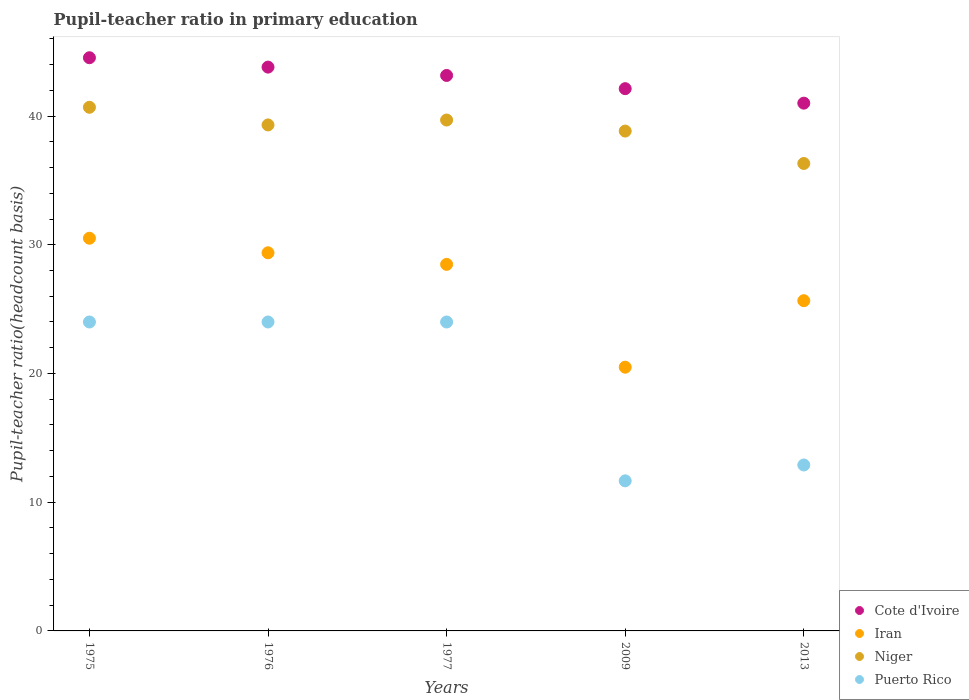How many different coloured dotlines are there?
Provide a short and direct response. 4. What is the pupil-teacher ratio in primary education in Niger in 2009?
Your answer should be compact. 38.83. Across all years, what is the maximum pupil-teacher ratio in primary education in Iran?
Provide a succinct answer. 30.51. Across all years, what is the minimum pupil-teacher ratio in primary education in Iran?
Make the answer very short. 20.49. In which year was the pupil-teacher ratio in primary education in Puerto Rico maximum?
Provide a succinct answer. 1976. In which year was the pupil-teacher ratio in primary education in Cote d'Ivoire minimum?
Make the answer very short. 2013. What is the total pupil-teacher ratio in primary education in Cote d'Ivoire in the graph?
Ensure brevity in your answer.  214.61. What is the difference between the pupil-teacher ratio in primary education in Niger in 1976 and that in 2013?
Your answer should be very brief. 2.99. What is the difference between the pupil-teacher ratio in primary education in Iran in 2013 and the pupil-teacher ratio in primary education in Cote d'Ivoire in 1977?
Provide a short and direct response. -17.5. What is the average pupil-teacher ratio in primary education in Iran per year?
Your response must be concise. 26.9. In the year 1977, what is the difference between the pupil-teacher ratio in primary education in Cote d'Ivoire and pupil-teacher ratio in primary education in Puerto Rico?
Ensure brevity in your answer.  19.15. What is the ratio of the pupil-teacher ratio in primary education in Niger in 1977 to that in 2013?
Make the answer very short. 1.09. What is the difference between the highest and the second highest pupil-teacher ratio in primary education in Cote d'Ivoire?
Offer a terse response. 0.73. What is the difference between the highest and the lowest pupil-teacher ratio in primary education in Cote d'Ivoire?
Provide a short and direct response. 3.53. Is it the case that in every year, the sum of the pupil-teacher ratio in primary education in Niger and pupil-teacher ratio in primary education in Iran  is greater than the pupil-teacher ratio in primary education in Puerto Rico?
Offer a very short reply. Yes. Is the pupil-teacher ratio in primary education in Niger strictly greater than the pupil-teacher ratio in primary education in Iran over the years?
Provide a succinct answer. Yes. Is the pupil-teacher ratio in primary education in Iran strictly less than the pupil-teacher ratio in primary education in Cote d'Ivoire over the years?
Offer a terse response. Yes. How many years are there in the graph?
Make the answer very short. 5. Where does the legend appear in the graph?
Make the answer very short. Bottom right. How many legend labels are there?
Provide a succinct answer. 4. What is the title of the graph?
Ensure brevity in your answer.  Pupil-teacher ratio in primary education. Does "Burkina Faso" appear as one of the legend labels in the graph?
Offer a terse response. No. What is the label or title of the Y-axis?
Keep it short and to the point. Pupil-teacher ratio(headcount basis). What is the Pupil-teacher ratio(headcount basis) of Cote d'Ivoire in 1975?
Ensure brevity in your answer.  44.53. What is the Pupil-teacher ratio(headcount basis) of Iran in 1975?
Provide a short and direct response. 30.51. What is the Pupil-teacher ratio(headcount basis) of Niger in 1975?
Offer a terse response. 40.68. What is the Pupil-teacher ratio(headcount basis) of Puerto Rico in 1975?
Your answer should be very brief. 24. What is the Pupil-teacher ratio(headcount basis) in Cote d'Ivoire in 1976?
Your answer should be compact. 43.8. What is the Pupil-teacher ratio(headcount basis) in Iran in 1976?
Keep it short and to the point. 29.38. What is the Pupil-teacher ratio(headcount basis) of Niger in 1976?
Provide a succinct answer. 39.31. What is the Pupil-teacher ratio(headcount basis) in Puerto Rico in 1976?
Your answer should be very brief. 24. What is the Pupil-teacher ratio(headcount basis) in Cote d'Ivoire in 1977?
Your answer should be very brief. 43.15. What is the Pupil-teacher ratio(headcount basis) of Iran in 1977?
Your answer should be very brief. 28.48. What is the Pupil-teacher ratio(headcount basis) in Niger in 1977?
Make the answer very short. 39.69. What is the Pupil-teacher ratio(headcount basis) of Puerto Rico in 1977?
Keep it short and to the point. 24. What is the Pupil-teacher ratio(headcount basis) in Cote d'Ivoire in 2009?
Offer a very short reply. 42.13. What is the Pupil-teacher ratio(headcount basis) in Iran in 2009?
Offer a very short reply. 20.49. What is the Pupil-teacher ratio(headcount basis) in Niger in 2009?
Provide a succinct answer. 38.83. What is the Pupil-teacher ratio(headcount basis) in Puerto Rico in 2009?
Keep it short and to the point. 11.66. What is the Pupil-teacher ratio(headcount basis) of Cote d'Ivoire in 2013?
Make the answer very short. 41. What is the Pupil-teacher ratio(headcount basis) of Iran in 2013?
Give a very brief answer. 25.65. What is the Pupil-teacher ratio(headcount basis) in Niger in 2013?
Keep it short and to the point. 36.31. What is the Pupil-teacher ratio(headcount basis) of Puerto Rico in 2013?
Give a very brief answer. 12.89. Across all years, what is the maximum Pupil-teacher ratio(headcount basis) in Cote d'Ivoire?
Keep it short and to the point. 44.53. Across all years, what is the maximum Pupil-teacher ratio(headcount basis) in Iran?
Ensure brevity in your answer.  30.51. Across all years, what is the maximum Pupil-teacher ratio(headcount basis) of Niger?
Your response must be concise. 40.68. Across all years, what is the maximum Pupil-teacher ratio(headcount basis) of Puerto Rico?
Ensure brevity in your answer.  24. Across all years, what is the minimum Pupil-teacher ratio(headcount basis) in Cote d'Ivoire?
Your response must be concise. 41. Across all years, what is the minimum Pupil-teacher ratio(headcount basis) of Iran?
Your answer should be very brief. 20.49. Across all years, what is the minimum Pupil-teacher ratio(headcount basis) of Niger?
Make the answer very short. 36.31. Across all years, what is the minimum Pupil-teacher ratio(headcount basis) in Puerto Rico?
Provide a succinct answer. 11.66. What is the total Pupil-teacher ratio(headcount basis) of Cote d'Ivoire in the graph?
Provide a succinct answer. 214.61. What is the total Pupil-teacher ratio(headcount basis) of Iran in the graph?
Provide a short and direct response. 134.5. What is the total Pupil-teacher ratio(headcount basis) of Niger in the graph?
Your response must be concise. 194.83. What is the total Pupil-teacher ratio(headcount basis) in Puerto Rico in the graph?
Keep it short and to the point. 96.55. What is the difference between the Pupil-teacher ratio(headcount basis) of Cote d'Ivoire in 1975 and that in 1976?
Offer a very short reply. 0.73. What is the difference between the Pupil-teacher ratio(headcount basis) in Iran in 1975 and that in 1976?
Make the answer very short. 1.13. What is the difference between the Pupil-teacher ratio(headcount basis) of Niger in 1975 and that in 1976?
Provide a succinct answer. 1.37. What is the difference between the Pupil-teacher ratio(headcount basis) of Puerto Rico in 1975 and that in 1976?
Provide a succinct answer. -0. What is the difference between the Pupil-teacher ratio(headcount basis) of Cote d'Ivoire in 1975 and that in 1977?
Your answer should be very brief. 1.38. What is the difference between the Pupil-teacher ratio(headcount basis) of Iran in 1975 and that in 1977?
Provide a succinct answer. 2.03. What is the difference between the Pupil-teacher ratio(headcount basis) in Niger in 1975 and that in 1977?
Make the answer very short. 0.99. What is the difference between the Pupil-teacher ratio(headcount basis) of Cote d'Ivoire in 1975 and that in 2009?
Your answer should be very brief. 2.4. What is the difference between the Pupil-teacher ratio(headcount basis) of Iran in 1975 and that in 2009?
Your response must be concise. 10.02. What is the difference between the Pupil-teacher ratio(headcount basis) in Niger in 1975 and that in 2009?
Keep it short and to the point. 1.85. What is the difference between the Pupil-teacher ratio(headcount basis) of Puerto Rico in 1975 and that in 2009?
Offer a very short reply. 12.34. What is the difference between the Pupil-teacher ratio(headcount basis) in Cote d'Ivoire in 1975 and that in 2013?
Your answer should be compact. 3.53. What is the difference between the Pupil-teacher ratio(headcount basis) in Iran in 1975 and that in 2013?
Offer a very short reply. 4.85. What is the difference between the Pupil-teacher ratio(headcount basis) of Niger in 1975 and that in 2013?
Provide a succinct answer. 4.37. What is the difference between the Pupil-teacher ratio(headcount basis) in Puerto Rico in 1975 and that in 2013?
Your response must be concise. 11.11. What is the difference between the Pupil-teacher ratio(headcount basis) of Cote d'Ivoire in 1976 and that in 1977?
Provide a succinct answer. 0.65. What is the difference between the Pupil-teacher ratio(headcount basis) in Iran in 1976 and that in 1977?
Ensure brevity in your answer.  0.9. What is the difference between the Pupil-teacher ratio(headcount basis) of Niger in 1976 and that in 1977?
Give a very brief answer. -0.38. What is the difference between the Pupil-teacher ratio(headcount basis) in Puerto Rico in 1976 and that in 1977?
Offer a very short reply. 0. What is the difference between the Pupil-teacher ratio(headcount basis) in Cote d'Ivoire in 1976 and that in 2009?
Provide a succinct answer. 1.67. What is the difference between the Pupil-teacher ratio(headcount basis) in Iran in 1976 and that in 2009?
Your answer should be compact. 8.89. What is the difference between the Pupil-teacher ratio(headcount basis) of Niger in 1976 and that in 2009?
Provide a short and direct response. 0.48. What is the difference between the Pupil-teacher ratio(headcount basis) of Puerto Rico in 1976 and that in 2009?
Your response must be concise. 12.34. What is the difference between the Pupil-teacher ratio(headcount basis) of Cote d'Ivoire in 1976 and that in 2013?
Your answer should be very brief. 2.8. What is the difference between the Pupil-teacher ratio(headcount basis) in Iran in 1976 and that in 2013?
Give a very brief answer. 3.72. What is the difference between the Pupil-teacher ratio(headcount basis) of Niger in 1976 and that in 2013?
Your answer should be compact. 2.99. What is the difference between the Pupil-teacher ratio(headcount basis) of Puerto Rico in 1976 and that in 2013?
Your response must be concise. 11.11. What is the difference between the Pupil-teacher ratio(headcount basis) in Cote d'Ivoire in 1977 and that in 2009?
Provide a succinct answer. 1.03. What is the difference between the Pupil-teacher ratio(headcount basis) of Iran in 1977 and that in 2009?
Your answer should be compact. 7.99. What is the difference between the Pupil-teacher ratio(headcount basis) of Niger in 1977 and that in 2009?
Provide a succinct answer. 0.86. What is the difference between the Pupil-teacher ratio(headcount basis) of Puerto Rico in 1977 and that in 2009?
Give a very brief answer. 12.34. What is the difference between the Pupil-teacher ratio(headcount basis) of Cote d'Ivoire in 1977 and that in 2013?
Give a very brief answer. 2.15. What is the difference between the Pupil-teacher ratio(headcount basis) in Iran in 1977 and that in 2013?
Your answer should be very brief. 2.82. What is the difference between the Pupil-teacher ratio(headcount basis) of Niger in 1977 and that in 2013?
Offer a terse response. 3.38. What is the difference between the Pupil-teacher ratio(headcount basis) of Puerto Rico in 1977 and that in 2013?
Offer a very short reply. 11.11. What is the difference between the Pupil-teacher ratio(headcount basis) in Cote d'Ivoire in 2009 and that in 2013?
Make the answer very short. 1.13. What is the difference between the Pupil-teacher ratio(headcount basis) of Iran in 2009 and that in 2013?
Provide a short and direct response. -5.17. What is the difference between the Pupil-teacher ratio(headcount basis) of Niger in 2009 and that in 2013?
Offer a very short reply. 2.52. What is the difference between the Pupil-teacher ratio(headcount basis) in Puerto Rico in 2009 and that in 2013?
Provide a short and direct response. -1.23. What is the difference between the Pupil-teacher ratio(headcount basis) in Cote d'Ivoire in 1975 and the Pupil-teacher ratio(headcount basis) in Iran in 1976?
Ensure brevity in your answer.  15.15. What is the difference between the Pupil-teacher ratio(headcount basis) in Cote d'Ivoire in 1975 and the Pupil-teacher ratio(headcount basis) in Niger in 1976?
Provide a short and direct response. 5.22. What is the difference between the Pupil-teacher ratio(headcount basis) of Cote d'Ivoire in 1975 and the Pupil-teacher ratio(headcount basis) of Puerto Rico in 1976?
Your response must be concise. 20.53. What is the difference between the Pupil-teacher ratio(headcount basis) of Iran in 1975 and the Pupil-teacher ratio(headcount basis) of Niger in 1976?
Ensure brevity in your answer.  -8.8. What is the difference between the Pupil-teacher ratio(headcount basis) of Iran in 1975 and the Pupil-teacher ratio(headcount basis) of Puerto Rico in 1976?
Give a very brief answer. 6.51. What is the difference between the Pupil-teacher ratio(headcount basis) of Niger in 1975 and the Pupil-teacher ratio(headcount basis) of Puerto Rico in 1976?
Offer a terse response. 16.68. What is the difference between the Pupil-teacher ratio(headcount basis) in Cote d'Ivoire in 1975 and the Pupil-teacher ratio(headcount basis) in Iran in 1977?
Offer a very short reply. 16.05. What is the difference between the Pupil-teacher ratio(headcount basis) in Cote d'Ivoire in 1975 and the Pupil-teacher ratio(headcount basis) in Niger in 1977?
Give a very brief answer. 4.84. What is the difference between the Pupil-teacher ratio(headcount basis) of Cote d'Ivoire in 1975 and the Pupil-teacher ratio(headcount basis) of Puerto Rico in 1977?
Your answer should be very brief. 20.53. What is the difference between the Pupil-teacher ratio(headcount basis) of Iran in 1975 and the Pupil-teacher ratio(headcount basis) of Niger in 1977?
Provide a short and direct response. -9.18. What is the difference between the Pupil-teacher ratio(headcount basis) of Iran in 1975 and the Pupil-teacher ratio(headcount basis) of Puerto Rico in 1977?
Your answer should be very brief. 6.51. What is the difference between the Pupil-teacher ratio(headcount basis) of Niger in 1975 and the Pupil-teacher ratio(headcount basis) of Puerto Rico in 1977?
Offer a terse response. 16.68. What is the difference between the Pupil-teacher ratio(headcount basis) in Cote d'Ivoire in 1975 and the Pupil-teacher ratio(headcount basis) in Iran in 2009?
Give a very brief answer. 24.04. What is the difference between the Pupil-teacher ratio(headcount basis) of Cote d'Ivoire in 1975 and the Pupil-teacher ratio(headcount basis) of Niger in 2009?
Provide a succinct answer. 5.7. What is the difference between the Pupil-teacher ratio(headcount basis) of Cote d'Ivoire in 1975 and the Pupil-teacher ratio(headcount basis) of Puerto Rico in 2009?
Offer a terse response. 32.87. What is the difference between the Pupil-teacher ratio(headcount basis) of Iran in 1975 and the Pupil-teacher ratio(headcount basis) of Niger in 2009?
Keep it short and to the point. -8.32. What is the difference between the Pupil-teacher ratio(headcount basis) in Iran in 1975 and the Pupil-teacher ratio(headcount basis) in Puerto Rico in 2009?
Your answer should be very brief. 18.85. What is the difference between the Pupil-teacher ratio(headcount basis) in Niger in 1975 and the Pupil-teacher ratio(headcount basis) in Puerto Rico in 2009?
Provide a succinct answer. 29.02. What is the difference between the Pupil-teacher ratio(headcount basis) in Cote d'Ivoire in 1975 and the Pupil-teacher ratio(headcount basis) in Iran in 2013?
Provide a short and direct response. 18.88. What is the difference between the Pupil-teacher ratio(headcount basis) of Cote d'Ivoire in 1975 and the Pupil-teacher ratio(headcount basis) of Niger in 2013?
Your response must be concise. 8.22. What is the difference between the Pupil-teacher ratio(headcount basis) of Cote d'Ivoire in 1975 and the Pupil-teacher ratio(headcount basis) of Puerto Rico in 2013?
Your answer should be very brief. 31.64. What is the difference between the Pupil-teacher ratio(headcount basis) in Iran in 1975 and the Pupil-teacher ratio(headcount basis) in Niger in 2013?
Your answer should be very brief. -5.81. What is the difference between the Pupil-teacher ratio(headcount basis) of Iran in 1975 and the Pupil-teacher ratio(headcount basis) of Puerto Rico in 2013?
Provide a short and direct response. 17.62. What is the difference between the Pupil-teacher ratio(headcount basis) of Niger in 1975 and the Pupil-teacher ratio(headcount basis) of Puerto Rico in 2013?
Keep it short and to the point. 27.79. What is the difference between the Pupil-teacher ratio(headcount basis) in Cote d'Ivoire in 1976 and the Pupil-teacher ratio(headcount basis) in Iran in 1977?
Provide a succinct answer. 15.33. What is the difference between the Pupil-teacher ratio(headcount basis) of Cote d'Ivoire in 1976 and the Pupil-teacher ratio(headcount basis) of Niger in 1977?
Keep it short and to the point. 4.11. What is the difference between the Pupil-teacher ratio(headcount basis) of Cote d'Ivoire in 1976 and the Pupil-teacher ratio(headcount basis) of Puerto Rico in 1977?
Your answer should be very brief. 19.8. What is the difference between the Pupil-teacher ratio(headcount basis) in Iran in 1976 and the Pupil-teacher ratio(headcount basis) in Niger in 1977?
Provide a short and direct response. -10.31. What is the difference between the Pupil-teacher ratio(headcount basis) in Iran in 1976 and the Pupil-teacher ratio(headcount basis) in Puerto Rico in 1977?
Your answer should be very brief. 5.38. What is the difference between the Pupil-teacher ratio(headcount basis) of Niger in 1976 and the Pupil-teacher ratio(headcount basis) of Puerto Rico in 1977?
Ensure brevity in your answer.  15.31. What is the difference between the Pupil-teacher ratio(headcount basis) in Cote d'Ivoire in 1976 and the Pupil-teacher ratio(headcount basis) in Iran in 2009?
Make the answer very short. 23.31. What is the difference between the Pupil-teacher ratio(headcount basis) in Cote d'Ivoire in 1976 and the Pupil-teacher ratio(headcount basis) in Niger in 2009?
Provide a succinct answer. 4.97. What is the difference between the Pupil-teacher ratio(headcount basis) in Cote d'Ivoire in 1976 and the Pupil-teacher ratio(headcount basis) in Puerto Rico in 2009?
Your response must be concise. 32.14. What is the difference between the Pupil-teacher ratio(headcount basis) of Iran in 1976 and the Pupil-teacher ratio(headcount basis) of Niger in 2009?
Provide a succinct answer. -9.46. What is the difference between the Pupil-teacher ratio(headcount basis) in Iran in 1976 and the Pupil-teacher ratio(headcount basis) in Puerto Rico in 2009?
Offer a very short reply. 17.72. What is the difference between the Pupil-teacher ratio(headcount basis) in Niger in 1976 and the Pupil-teacher ratio(headcount basis) in Puerto Rico in 2009?
Your answer should be very brief. 27.65. What is the difference between the Pupil-teacher ratio(headcount basis) of Cote d'Ivoire in 1976 and the Pupil-teacher ratio(headcount basis) of Iran in 2013?
Make the answer very short. 18.15. What is the difference between the Pupil-teacher ratio(headcount basis) of Cote d'Ivoire in 1976 and the Pupil-teacher ratio(headcount basis) of Niger in 2013?
Offer a terse response. 7.49. What is the difference between the Pupil-teacher ratio(headcount basis) of Cote d'Ivoire in 1976 and the Pupil-teacher ratio(headcount basis) of Puerto Rico in 2013?
Your answer should be very brief. 30.91. What is the difference between the Pupil-teacher ratio(headcount basis) in Iran in 1976 and the Pupil-teacher ratio(headcount basis) in Niger in 2013?
Give a very brief answer. -6.94. What is the difference between the Pupil-teacher ratio(headcount basis) in Iran in 1976 and the Pupil-teacher ratio(headcount basis) in Puerto Rico in 2013?
Your answer should be compact. 16.48. What is the difference between the Pupil-teacher ratio(headcount basis) in Niger in 1976 and the Pupil-teacher ratio(headcount basis) in Puerto Rico in 2013?
Your answer should be compact. 26.42. What is the difference between the Pupil-teacher ratio(headcount basis) in Cote d'Ivoire in 1977 and the Pupil-teacher ratio(headcount basis) in Iran in 2009?
Your answer should be compact. 22.67. What is the difference between the Pupil-teacher ratio(headcount basis) in Cote d'Ivoire in 1977 and the Pupil-teacher ratio(headcount basis) in Niger in 2009?
Offer a very short reply. 4.32. What is the difference between the Pupil-teacher ratio(headcount basis) in Cote d'Ivoire in 1977 and the Pupil-teacher ratio(headcount basis) in Puerto Rico in 2009?
Your response must be concise. 31.49. What is the difference between the Pupil-teacher ratio(headcount basis) of Iran in 1977 and the Pupil-teacher ratio(headcount basis) of Niger in 2009?
Give a very brief answer. -10.36. What is the difference between the Pupil-teacher ratio(headcount basis) in Iran in 1977 and the Pupil-teacher ratio(headcount basis) in Puerto Rico in 2009?
Give a very brief answer. 16.82. What is the difference between the Pupil-teacher ratio(headcount basis) in Niger in 1977 and the Pupil-teacher ratio(headcount basis) in Puerto Rico in 2009?
Offer a terse response. 28.03. What is the difference between the Pupil-teacher ratio(headcount basis) of Cote d'Ivoire in 1977 and the Pupil-teacher ratio(headcount basis) of Iran in 2013?
Keep it short and to the point. 17.5. What is the difference between the Pupil-teacher ratio(headcount basis) in Cote d'Ivoire in 1977 and the Pupil-teacher ratio(headcount basis) in Niger in 2013?
Your answer should be very brief. 6.84. What is the difference between the Pupil-teacher ratio(headcount basis) in Cote d'Ivoire in 1977 and the Pupil-teacher ratio(headcount basis) in Puerto Rico in 2013?
Ensure brevity in your answer.  30.26. What is the difference between the Pupil-teacher ratio(headcount basis) of Iran in 1977 and the Pupil-teacher ratio(headcount basis) of Niger in 2013?
Make the answer very short. -7.84. What is the difference between the Pupil-teacher ratio(headcount basis) of Iran in 1977 and the Pupil-teacher ratio(headcount basis) of Puerto Rico in 2013?
Your response must be concise. 15.58. What is the difference between the Pupil-teacher ratio(headcount basis) of Niger in 1977 and the Pupil-teacher ratio(headcount basis) of Puerto Rico in 2013?
Your response must be concise. 26.8. What is the difference between the Pupil-teacher ratio(headcount basis) in Cote d'Ivoire in 2009 and the Pupil-teacher ratio(headcount basis) in Iran in 2013?
Provide a short and direct response. 16.47. What is the difference between the Pupil-teacher ratio(headcount basis) of Cote d'Ivoire in 2009 and the Pupil-teacher ratio(headcount basis) of Niger in 2013?
Provide a succinct answer. 5.81. What is the difference between the Pupil-teacher ratio(headcount basis) of Cote d'Ivoire in 2009 and the Pupil-teacher ratio(headcount basis) of Puerto Rico in 2013?
Your answer should be very brief. 29.24. What is the difference between the Pupil-teacher ratio(headcount basis) in Iran in 2009 and the Pupil-teacher ratio(headcount basis) in Niger in 2013?
Make the answer very short. -15.83. What is the difference between the Pupil-teacher ratio(headcount basis) of Iran in 2009 and the Pupil-teacher ratio(headcount basis) of Puerto Rico in 2013?
Ensure brevity in your answer.  7.6. What is the difference between the Pupil-teacher ratio(headcount basis) in Niger in 2009 and the Pupil-teacher ratio(headcount basis) in Puerto Rico in 2013?
Your response must be concise. 25.94. What is the average Pupil-teacher ratio(headcount basis) in Cote d'Ivoire per year?
Offer a very short reply. 42.92. What is the average Pupil-teacher ratio(headcount basis) in Iran per year?
Provide a short and direct response. 26.9. What is the average Pupil-teacher ratio(headcount basis) in Niger per year?
Offer a terse response. 38.97. What is the average Pupil-teacher ratio(headcount basis) in Puerto Rico per year?
Your answer should be very brief. 19.31. In the year 1975, what is the difference between the Pupil-teacher ratio(headcount basis) in Cote d'Ivoire and Pupil-teacher ratio(headcount basis) in Iran?
Offer a very short reply. 14.02. In the year 1975, what is the difference between the Pupil-teacher ratio(headcount basis) of Cote d'Ivoire and Pupil-teacher ratio(headcount basis) of Niger?
Provide a short and direct response. 3.85. In the year 1975, what is the difference between the Pupil-teacher ratio(headcount basis) of Cote d'Ivoire and Pupil-teacher ratio(headcount basis) of Puerto Rico?
Ensure brevity in your answer.  20.53. In the year 1975, what is the difference between the Pupil-teacher ratio(headcount basis) in Iran and Pupil-teacher ratio(headcount basis) in Niger?
Your answer should be very brief. -10.17. In the year 1975, what is the difference between the Pupil-teacher ratio(headcount basis) in Iran and Pupil-teacher ratio(headcount basis) in Puerto Rico?
Give a very brief answer. 6.51. In the year 1975, what is the difference between the Pupil-teacher ratio(headcount basis) of Niger and Pupil-teacher ratio(headcount basis) of Puerto Rico?
Offer a very short reply. 16.68. In the year 1976, what is the difference between the Pupil-teacher ratio(headcount basis) of Cote d'Ivoire and Pupil-teacher ratio(headcount basis) of Iran?
Keep it short and to the point. 14.43. In the year 1976, what is the difference between the Pupil-teacher ratio(headcount basis) in Cote d'Ivoire and Pupil-teacher ratio(headcount basis) in Niger?
Your answer should be very brief. 4.49. In the year 1976, what is the difference between the Pupil-teacher ratio(headcount basis) in Cote d'Ivoire and Pupil-teacher ratio(headcount basis) in Puerto Rico?
Give a very brief answer. 19.8. In the year 1976, what is the difference between the Pupil-teacher ratio(headcount basis) of Iran and Pupil-teacher ratio(headcount basis) of Niger?
Keep it short and to the point. -9.93. In the year 1976, what is the difference between the Pupil-teacher ratio(headcount basis) of Iran and Pupil-teacher ratio(headcount basis) of Puerto Rico?
Your response must be concise. 5.37. In the year 1976, what is the difference between the Pupil-teacher ratio(headcount basis) in Niger and Pupil-teacher ratio(headcount basis) in Puerto Rico?
Keep it short and to the point. 15.31. In the year 1977, what is the difference between the Pupil-teacher ratio(headcount basis) in Cote d'Ivoire and Pupil-teacher ratio(headcount basis) in Iran?
Provide a succinct answer. 14.68. In the year 1977, what is the difference between the Pupil-teacher ratio(headcount basis) of Cote d'Ivoire and Pupil-teacher ratio(headcount basis) of Niger?
Provide a succinct answer. 3.46. In the year 1977, what is the difference between the Pupil-teacher ratio(headcount basis) in Cote d'Ivoire and Pupil-teacher ratio(headcount basis) in Puerto Rico?
Ensure brevity in your answer.  19.15. In the year 1977, what is the difference between the Pupil-teacher ratio(headcount basis) in Iran and Pupil-teacher ratio(headcount basis) in Niger?
Offer a very short reply. -11.21. In the year 1977, what is the difference between the Pupil-teacher ratio(headcount basis) of Iran and Pupil-teacher ratio(headcount basis) of Puerto Rico?
Provide a succinct answer. 4.48. In the year 1977, what is the difference between the Pupil-teacher ratio(headcount basis) of Niger and Pupil-teacher ratio(headcount basis) of Puerto Rico?
Your answer should be compact. 15.69. In the year 2009, what is the difference between the Pupil-teacher ratio(headcount basis) in Cote d'Ivoire and Pupil-teacher ratio(headcount basis) in Iran?
Ensure brevity in your answer.  21.64. In the year 2009, what is the difference between the Pupil-teacher ratio(headcount basis) of Cote d'Ivoire and Pupil-teacher ratio(headcount basis) of Niger?
Your response must be concise. 3.3. In the year 2009, what is the difference between the Pupil-teacher ratio(headcount basis) in Cote d'Ivoire and Pupil-teacher ratio(headcount basis) in Puerto Rico?
Make the answer very short. 30.47. In the year 2009, what is the difference between the Pupil-teacher ratio(headcount basis) in Iran and Pupil-teacher ratio(headcount basis) in Niger?
Offer a terse response. -18.34. In the year 2009, what is the difference between the Pupil-teacher ratio(headcount basis) of Iran and Pupil-teacher ratio(headcount basis) of Puerto Rico?
Provide a short and direct response. 8.83. In the year 2009, what is the difference between the Pupil-teacher ratio(headcount basis) in Niger and Pupil-teacher ratio(headcount basis) in Puerto Rico?
Your answer should be very brief. 27.17. In the year 2013, what is the difference between the Pupil-teacher ratio(headcount basis) of Cote d'Ivoire and Pupil-teacher ratio(headcount basis) of Iran?
Your answer should be compact. 15.35. In the year 2013, what is the difference between the Pupil-teacher ratio(headcount basis) of Cote d'Ivoire and Pupil-teacher ratio(headcount basis) of Niger?
Keep it short and to the point. 4.69. In the year 2013, what is the difference between the Pupil-teacher ratio(headcount basis) of Cote d'Ivoire and Pupil-teacher ratio(headcount basis) of Puerto Rico?
Provide a short and direct response. 28.11. In the year 2013, what is the difference between the Pupil-teacher ratio(headcount basis) of Iran and Pupil-teacher ratio(headcount basis) of Niger?
Provide a short and direct response. -10.66. In the year 2013, what is the difference between the Pupil-teacher ratio(headcount basis) of Iran and Pupil-teacher ratio(headcount basis) of Puerto Rico?
Your answer should be very brief. 12.76. In the year 2013, what is the difference between the Pupil-teacher ratio(headcount basis) of Niger and Pupil-teacher ratio(headcount basis) of Puerto Rico?
Make the answer very short. 23.42. What is the ratio of the Pupil-teacher ratio(headcount basis) of Cote d'Ivoire in 1975 to that in 1976?
Offer a very short reply. 1.02. What is the ratio of the Pupil-teacher ratio(headcount basis) in Niger in 1975 to that in 1976?
Provide a short and direct response. 1.03. What is the ratio of the Pupil-teacher ratio(headcount basis) of Cote d'Ivoire in 1975 to that in 1977?
Provide a succinct answer. 1.03. What is the ratio of the Pupil-teacher ratio(headcount basis) of Iran in 1975 to that in 1977?
Provide a short and direct response. 1.07. What is the ratio of the Pupil-teacher ratio(headcount basis) of Puerto Rico in 1975 to that in 1977?
Provide a short and direct response. 1. What is the ratio of the Pupil-teacher ratio(headcount basis) in Cote d'Ivoire in 1975 to that in 2009?
Provide a succinct answer. 1.06. What is the ratio of the Pupil-teacher ratio(headcount basis) of Iran in 1975 to that in 2009?
Ensure brevity in your answer.  1.49. What is the ratio of the Pupil-teacher ratio(headcount basis) in Niger in 1975 to that in 2009?
Ensure brevity in your answer.  1.05. What is the ratio of the Pupil-teacher ratio(headcount basis) in Puerto Rico in 1975 to that in 2009?
Make the answer very short. 2.06. What is the ratio of the Pupil-teacher ratio(headcount basis) in Cote d'Ivoire in 1975 to that in 2013?
Your answer should be very brief. 1.09. What is the ratio of the Pupil-teacher ratio(headcount basis) in Iran in 1975 to that in 2013?
Provide a succinct answer. 1.19. What is the ratio of the Pupil-teacher ratio(headcount basis) in Niger in 1975 to that in 2013?
Your answer should be compact. 1.12. What is the ratio of the Pupil-teacher ratio(headcount basis) in Puerto Rico in 1975 to that in 2013?
Give a very brief answer. 1.86. What is the ratio of the Pupil-teacher ratio(headcount basis) in Cote d'Ivoire in 1976 to that in 1977?
Provide a short and direct response. 1.01. What is the ratio of the Pupil-teacher ratio(headcount basis) of Iran in 1976 to that in 1977?
Offer a terse response. 1.03. What is the ratio of the Pupil-teacher ratio(headcount basis) of Puerto Rico in 1976 to that in 1977?
Make the answer very short. 1. What is the ratio of the Pupil-teacher ratio(headcount basis) in Cote d'Ivoire in 1976 to that in 2009?
Your response must be concise. 1.04. What is the ratio of the Pupil-teacher ratio(headcount basis) of Iran in 1976 to that in 2009?
Make the answer very short. 1.43. What is the ratio of the Pupil-teacher ratio(headcount basis) of Niger in 1976 to that in 2009?
Offer a very short reply. 1.01. What is the ratio of the Pupil-teacher ratio(headcount basis) of Puerto Rico in 1976 to that in 2009?
Provide a short and direct response. 2.06. What is the ratio of the Pupil-teacher ratio(headcount basis) of Cote d'Ivoire in 1976 to that in 2013?
Provide a succinct answer. 1.07. What is the ratio of the Pupil-teacher ratio(headcount basis) in Iran in 1976 to that in 2013?
Keep it short and to the point. 1.15. What is the ratio of the Pupil-teacher ratio(headcount basis) in Niger in 1976 to that in 2013?
Provide a succinct answer. 1.08. What is the ratio of the Pupil-teacher ratio(headcount basis) in Puerto Rico in 1976 to that in 2013?
Provide a short and direct response. 1.86. What is the ratio of the Pupil-teacher ratio(headcount basis) in Cote d'Ivoire in 1977 to that in 2009?
Provide a short and direct response. 1.02. What is the ratio of the Pupil-teacher ratio(headcount basis) in Iran in 1977 to that in 2009?
Your answer should be compact. 1.39. What is the ratio of the Pupil-teacher ratio(headcount basis) of Niger in 1977 to that in 2009?
Ensure brevity in your answer.  1.02. What is the ratio of the Pupil-teacher ratio(headcount basis) of Puerto Rico in 1977 to that in 2009?
Offer a very short reply. 2.06. What is the ratio of the Pupil-teacher ratio(headcount basis) of Cote d'Ivoire in 1977 to that in 2013?
Make the answer very short. 1.05. What is the ratio of the Pupil-teacher ratio(headcount basis) in Iran in 1977 to that in 2013?
Offer a terse response. 1.11. What is the ratio of the Pupil-teacher ratio(headcount basis) of Niger in 1977 to that in 2013?
Provide a succinct answer. 1.09. What is the ratio of the Pupil-teacher ratio(headcount basis) in Puerto Rico in 1977 to that in 2013?
Make the answer very short. 1.86. What is the ratio of the Pupil-teacher ratio(headcount basis) in Cote d'Ivoire in 2009 to that in 2013?
Offer a very short reply. 1.03. What is the ratio of the Pupil-teacher ratio(headcount basis) in Iran in 2009 to that in 2013?
Keep it short and to the point. 0.8. What is the ratio of the Pupil-teacher ratio(headcount basis) in Niger in 2009 to that in 2013?
Make the answer very short. 1.07. What is the ratio of the Pupil-teacher ratio(headcount basis) of Puerto Rico in 2009 to that in 2013?
Ensure brevity in your answer.  0.9. What is the difference between the highest and the second highest Pupil-teacher ratio(headcount basis) in Cote d'Ivoire?
Your answer should be very brief. 0.73. What is the difference between the highest and the second highest Pupil-teacher ratio(headcount basis) of Iran?
Offer a very short reply. 1.13. What is the difference between the highest and the second highest Pupil-teacher ratio(headcount basis) in Niger?
Keep it short and to the point. 0.99. What is the difference between the highest and the second highest Pupil-teacher ratio(headcount basis) of Puerto Rico?
Offer a very short reply. 0. What is the difference between the highest and the lowest Pupil-teacher ratio(headcount basis) in Cote d'Ivoire?
Provide a succinct answer. 3.53. What is the difference between the highest and the lowest Pupil-teacher ratio(headcount basis) of Iran?
Your answer should be very brief. 10.02. What is the difference between the highest and the lowest Pupil-teacher ratio(headcount basis) of Niger?
Ensure brevity in your answer.  4.37. What is the difference between the highest and the lowest Pupil-teacher ratio(headcount basis) in Puerto Rico?
Your response must be concise. 12.34. 